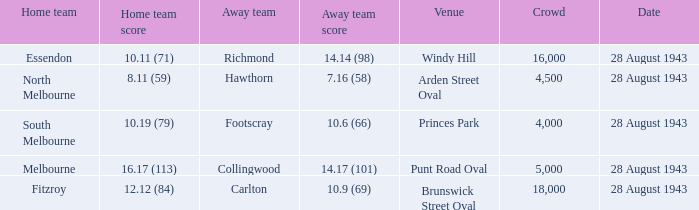In which venue was the contest played with a guest team score of 1 Punt Road Oval. 